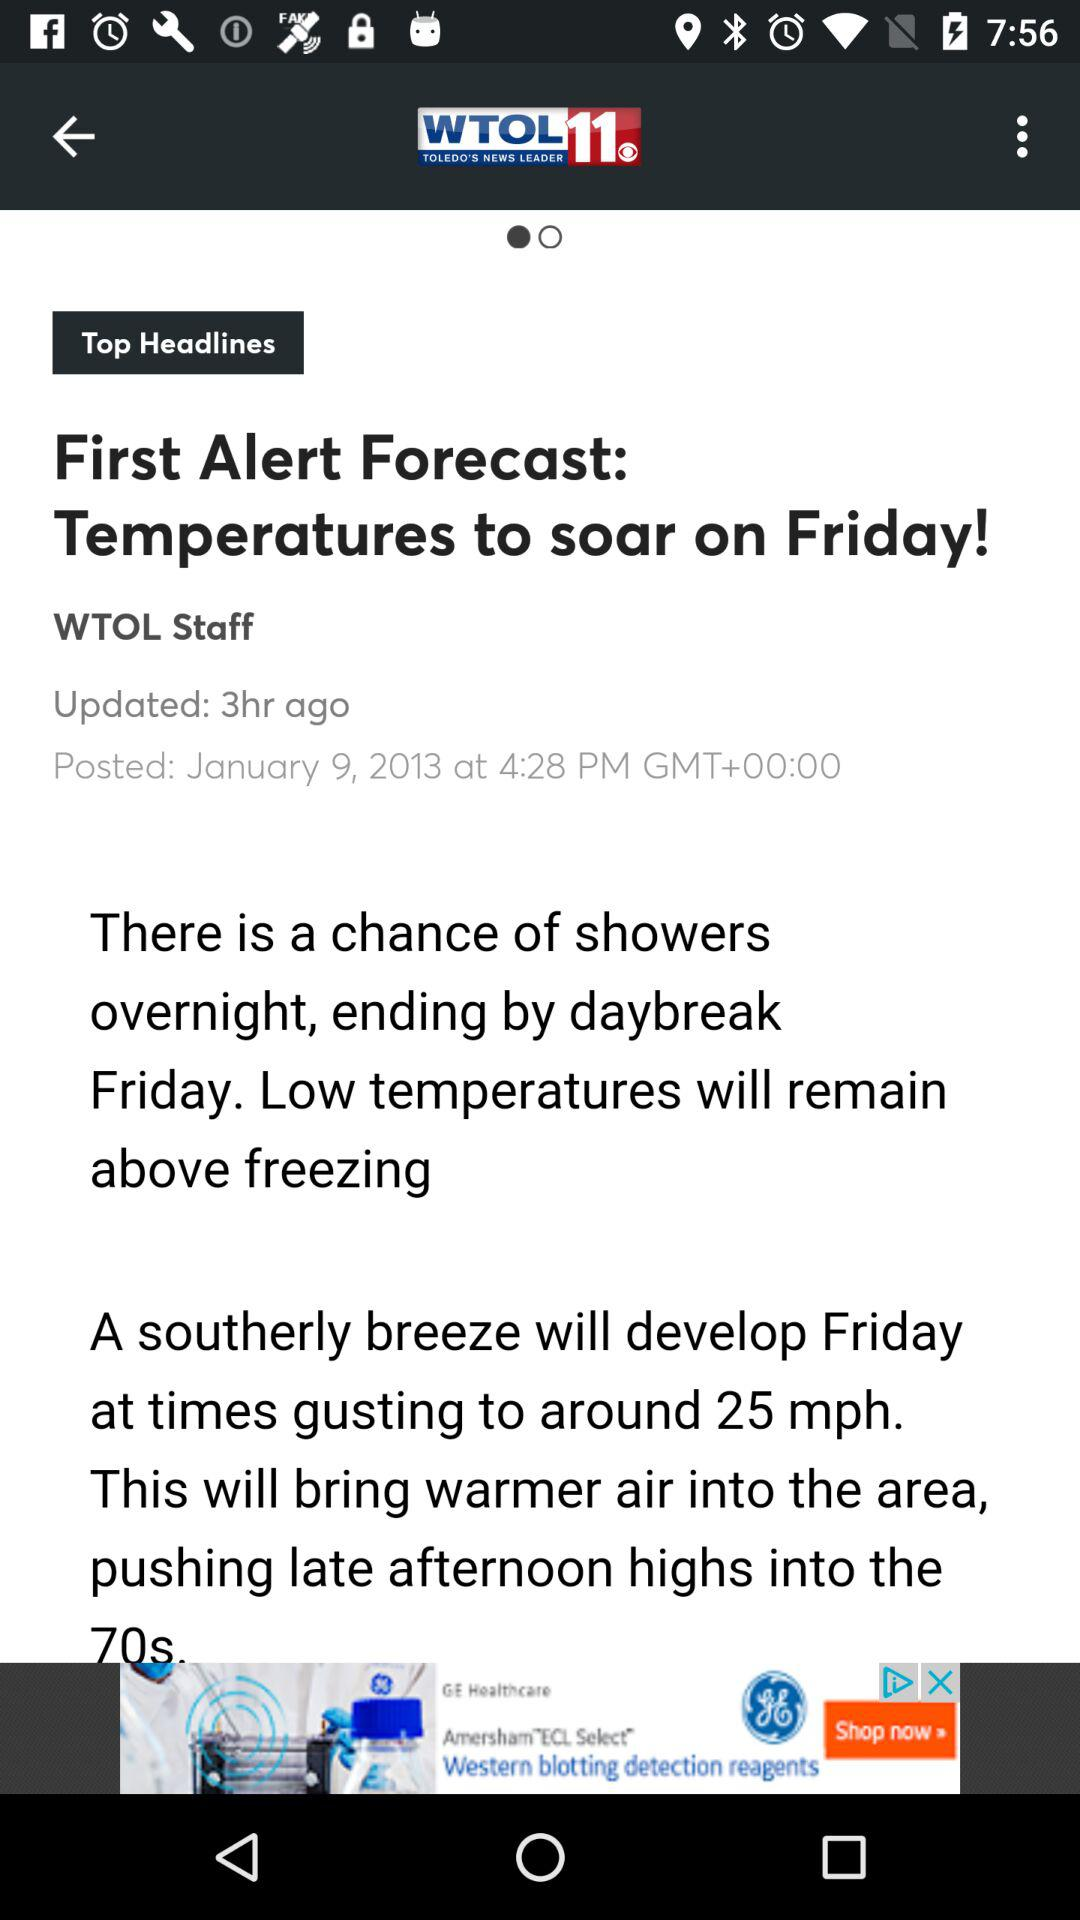When was the article posted? The article was posted on January 9, 2013 at 4:28 PM. 